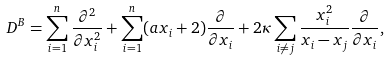<formula> <loc_0><loc_0><loc_500><loc_500>D ^ { B } = \sum _ { i = 1 } ^ { n } \frac { \partial ^ { 2 } } { \partial x _ { i } ^ { 2 } } + \sum _ { i = 1 } ^ { n } ( a x _ { i } + 2 ) \frac { \partial } { \partial x _ { i } } + 2 \kappa \sum _ { i \neq j } \frac { x _ { i } ^ { 2 } } { x _ { i } - x _ { j } } \frac { \partial } { \partial x _ { i } } ,</formula> 